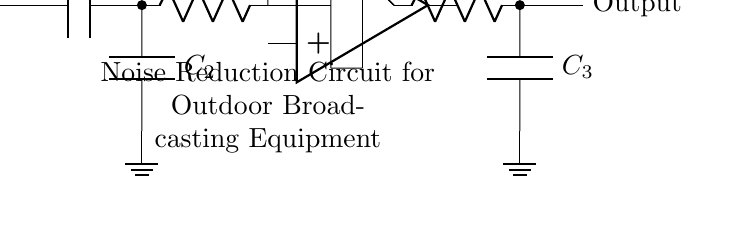What is the function of C1? C1 serves as a coupling capacitor that blocks any DC component and allows AC signals to pass. It is positioned at the input and is essential for noise reduction by filtering unwanted DC bias.
Answer: Coupling capacitor What type of filter is implemented at the input stage? The input stage employs a high-pass filter, which is created by the combination of C2 and R1. This filter allows high-frequency signals to pass while attenuating low-frequency noise.
Answer: High-pass filter What is the purpose of the op-amp in this circuit? The op-amp is used for amplification, providing gain to the signal processed through the circuit. It is central to improving the output strength of the desired signal while minimizing noise.
Answer: Amplification What components make up the low-pass filter? The low-pass filter consists of R3 and C3, which work together to allow low-frequency signals to pass through while blocking higher frequencies, thus reducing noise further down the line.
Answer: R3 and C3 What does R2 do in the feedback loop? R2 provides feedback to the op-amp, which helps to stabilize the output signal and control the gain of the amplifier, ensuring consistent performance in noise reduction applications.
Answer: Feedback control How many major components are in this circuit? The circuit contains five major components: C1, R1, C2, op-amp, R2, R3, and C3, which together form the complete noise reduction circuit.
Answer: Seven components 